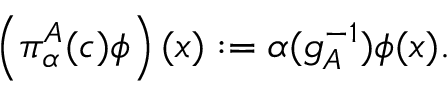<formula> <loc_0><loc_0><loc_500><loc_500>\left ( \pi _ { \alpha } ^ { A } ( c ) \phi \right ) ( x ) \colon = \alpha ( g _ { A } ^ { - 1 } ) \phi ( x ) .</formula> 